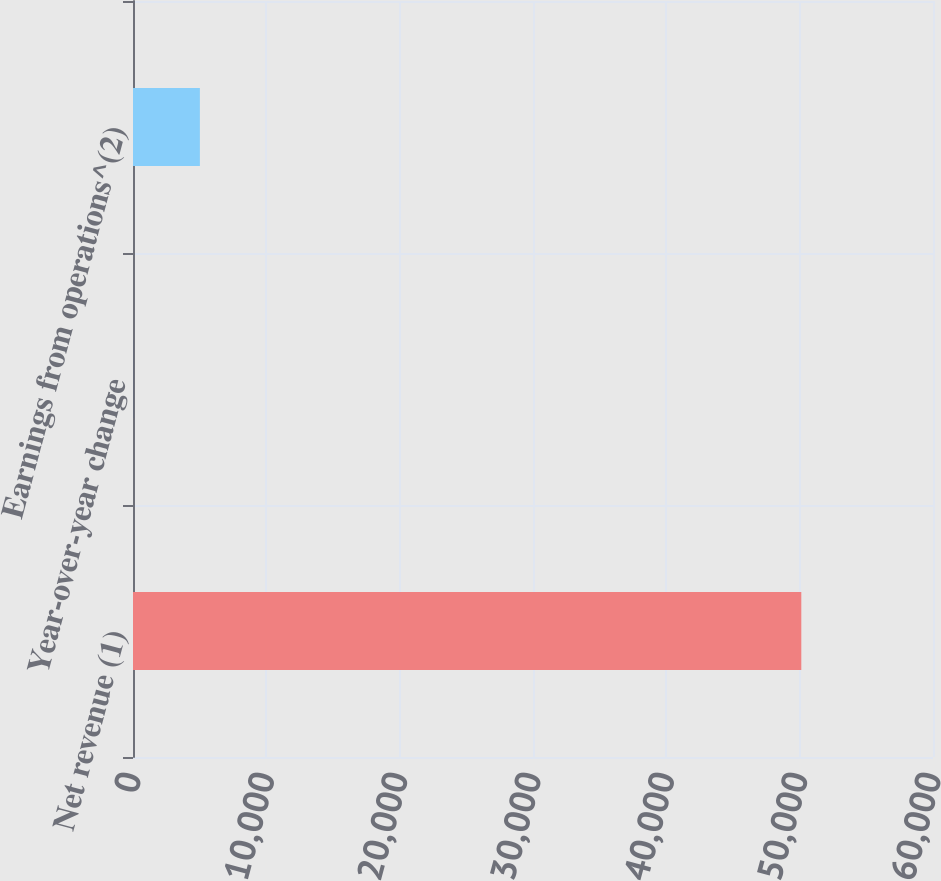Convert chart. <chart><loc_0><loc_0><loc_500><loc_500><bar_chart><fcel>Net revenue (1)<fcel>Year-over-year change<fcel>Earnings from operations^(2)<nl><fcel>50123<fcel>3.8<fcel>5015.72<nl></chart> 